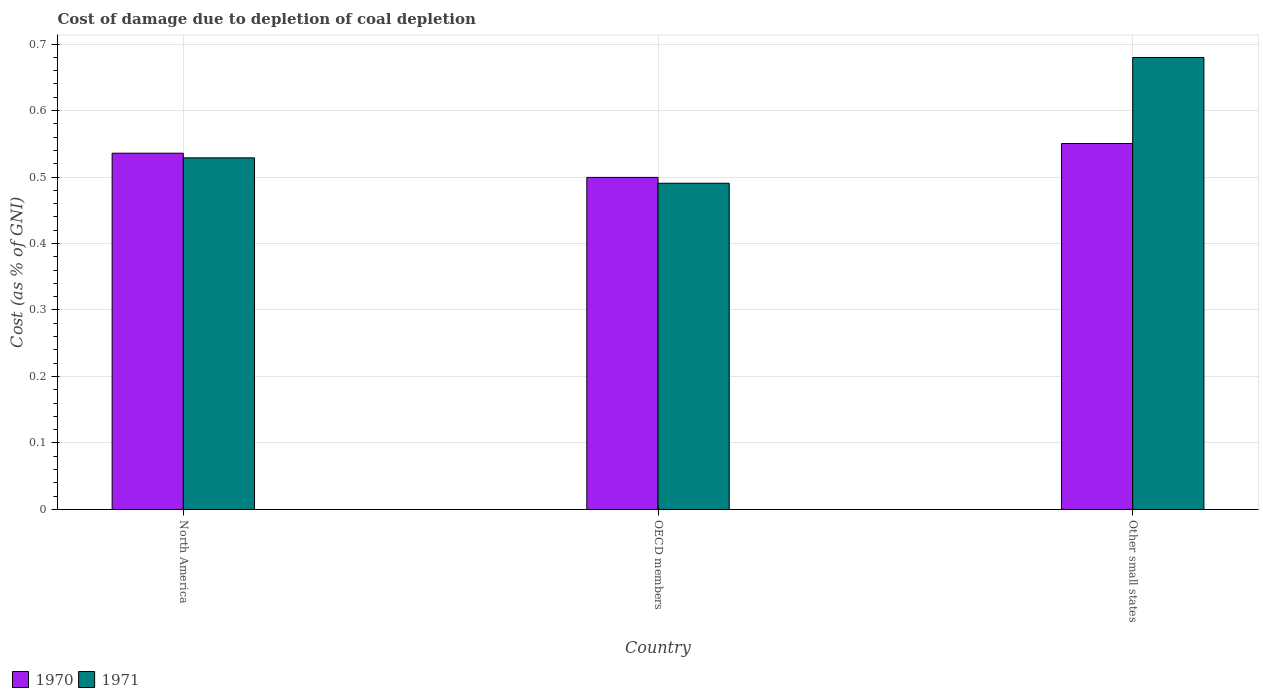How many groups of bars are there?
Give a very brief answer. 3. Are the number of bars per tick equal to the number of legend labels?
Give a very brief answer. Yes. Are the number of bars on each tick of the X-axis equal?
Your answer should be compact. Yes. How many bars are there on the 1st tick from the left?
Offer a terse response. 2. How many bars are there on the 2nd tick from the right?
Your answer should be compact. 2. What is the label of the 3rd group of bars from the left?
Offer a very short reply. Other small states. In how many cases, is the number of bars for a given country not equal to the number of legend labels?
Your answer should be very brief. 0. What is the cost of damage caused due to coal depletion in 1970 in Other small states?
Offer a terse response. 0.55. Across all countries, what is the maximum cost of damage caused due to coal depletion in 1970?
Offer a very short reply. 0.55. Across all countries, what is the minimum cost of damage caused due to coal depletion in 1971?
Provide a short and direct response. 0.49. In which country was the cost of damage caused due to coal depletion in 1970 maximum?
Provide a succinct answer. Other small states. In which country was the cost of damage caused due to coal depletion in 1971 minimum?
Your response must be concise. OECD members. What is the total cost of damage caused due to coal depletion in 1971 in the graph?
Your answer should be very brief. 1.7. What is the difference between the cost of damage caused due to coal depletion in 1971 in OECD members and that in Other small states?
Ensure brevity in your answer.  -0.19. What is the difference between the cost of damage caused due to coal depletion in 1971 in Other small states and the cost of damage caused due to coal depletion in 1970 in OECD members?
Your response must be concise. 0.18. What is the average cost of damage caused due to coal depletion in 1970 per country?
Your answer should be compact. 0.53. What is the difference between the cost of damage caused due to coal depletion of/in 1970 and cost of damage caused due to coal depletion of/in 1971 in North America?
Your answer should be very brief. 0.01. In how many countries, is the cost of damage caused due to coal depletion in 1970 greater than 0.06 %?
Your response must be concise. 3. What is the ratio of the cost of damage caused due to coal depletion in 1970 in North America to that in Other small states?
Give a very brief answer. 0.97. Is the cost of damage caused due to coal depletion in 1970 in North America less than that in Other small states?
Make the answer very short. Yes. What is the difference between the highest and the second highest cost of damage caused due to coal depletion in 1971?
Ensure brevity in your answer.  0.15. What is the difference between the highest and the lowest cost of damage caused due to coal depletion in 1971?
Provide a succinct answer. 0.19. In how many countries, is the cost of damage caused due to coal depletion in 1970 greater than the average cost of damage caused due to coal depletion in 1970 taken over all countries?
Offer a terse response. 2. Is the sum of the cost of damage caused due to coal depletion in 1970 in North America and OECD members greater than the maximum cost of damage caused due to coal depletion in 1971 across all countries?
Offer a terse response. Yes. What does the 2nd bar from the right in Other small states represents?
Make the answer very short. 1970. How many bars are there?
Make the answer very short. 6. How many countries are there in the graph?
Make the answer very short. 3. What is the difference between two consecutive major ticks on the Y-axis?
Offer a terse response. 0.1. Does the graph contain grids?
Offer a very short reply. Yes. Where does the legend appear in the graph?
Keep it short and to the point. Bottom left. What is the title of the graph?
Offer a very short reply. Cost of damage due to depletion of coal depletion. Does "1992" appear as one of the legend labels in the graph?
Offer a very short reply. No. What is the label or title of the Y-axis?
Your answer should be compact. Cost (as % of GNI). What is the Cost (as % of GNI) in 1970 in North America?
Your response must be concise. 0.54. What is the Cost (as % of GNI) of 1971 in North America?
Provide a succinct answer. 0.53. What is the Cost (as % of GNI) in 1970 in OECD members?
Keep it short and to the point. 0.5. What is the Cost (as % of GNI) in 1971 in OECD members?
Your response must be concise. 0.49. What is the Cost (as % of GNI) in 1970 in Other small states?
Keep it short and to the point. 0.55. What is the Cost (as % of GNI) of 1971 in Other small states?
Your answer should be very brief. 0.68. Across all countries, what is the maximum Cost (as % of GNI) of 1970?
Provide a succinct answer. 0.55. Across all countries, what is the maximum Cost (as % of GNI) in 1971?
Keep it short and to the point. 0.68. Across all countries, what is the minimum Cost (as % of GNI) in 1970?
Give a very brief answer. 0.5. Across all countries, what is the minimum Cost (as % of GNI) in 1971?
Provide a short and direct response. 0.49. What is the total Cost (as % of GNI) in 1970 in the graph?
Provide a short and direct response. 1.59. What is the total Cost (as % of GNI) of 1971 in the graph?
Your answer should be very brief. 1.7. What is the difference between the Cost (as % of GNI) of 1970 in North America and that in OECD members?
Provide a short and direct response. 0.04. What is the difference between the Cost (as % of GNI) in 1971 in North America and that in OECD members?
Your answer should be compact. 0.04. What is the difference between the Cost (as % of GNI) in 1970 in North America and that in Other small states?
Your answer should be very brief. -0.01. What is the difference between the Cost (as % of GNI) of 1971 in North America and that in Other small states?
Provide a succinct answer. -0.15. What is the difference between the Cost (as % of GNI) in 1970 in OECD members and that in Other small states?
Your response must be concise. -0.05. What is the difference between the Cost (as % of GNI) in 1971 in OECD members and that in Other small states?
Give a very brief answer. -0.19. What is the difference between the Cost (as % of GNI) in 1970 in North America and the Cost (as % of GNI) in 1971 in OECD members?
Make the answer very short. 0.05. What is the difference between the Cost (as % of GNI) of 1970 in North America and the Cost (as % of GNI) of 1971 in Other small states?
Your answer should be very brief. -0.14. What is the difference between the Cost (as % of GNI) in 1970 in OECD members and the Cost (as % of GNI) in 1971 in Other small states?
Ensure brevity in your answer.  -0.18. What is the average Cost (as % of GNI) in 1970 per country?
Provide a short and direct response. 0.53. What is the average Cost (as % of GNI) of 1971 per country?
Keep it short and to the point. 0.57. What is the difference between the Cost (as % of GNI) in 1970 and Cost (as % of GNI) in 1971 in North America?
Keep it short and to the point. 0.01. What is the difference between the Cost (as % of GNI) of 1970 and Cost (as % of GNI) of 1971 in OECD members?
Give a very brief answer. 0.01. What is the difference between the Cost (as % of GNI) of 1970 and Cost (as % of GNI) of 1971 in Other small states?
Your answer should be compact. -0.13. What is the ratio of the Cost (as % of GNI) in 1970 in North America to that in OECD members?
Offer a terse response. 1.07. What is the ratio of the Cost (as % of GNI) in 1971 in North America to that in OECD members?
Your response must be concise. 1.08. What is the ratio of the Cost (as % of GNI) in 1970 in North America to that in Other small states?
Offer a terse response. 0.97. What is the ratio of the Cost (as % of GNI) of 1971 in North America to that in Other small states?
Provide a succinct answer. 0.78. What is the ratio of the Cost (as % of GNI) of 1970 in OECD members to that in Other small states?
Your answer should be compact. 0.91. What is the ratio of the Cost (as % of GNI) of 1971 in OECD members to that in Other small states?
Offer a terse response. 0.72. What is the difference between the highest and the second highest Cost (as % of GNI) of 1970?
Offer a terse response. 0.01. What is the difference between the highest and the second highest Cost (as % of GNI) in 1971?
Your answer should be very brief. 0.15. What is the difference between the highest and the lowest Cost (as % of GNI) of 1970?
Provide a short and direct response. 0.05. What is the difference between the highest and the lowest Cost (as % of GNI) of 1971?
Keep it short and to the point. 0.19. 